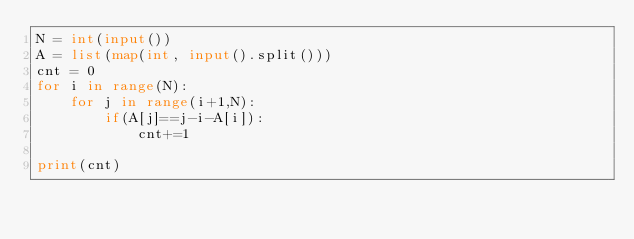<code> <loc_0><loc_0><loc_500><loc_500><_Python_>N = int(input())
A = list(map(int, input().split()))
cnt = 0 
for i in range(N):
    for j in range(i+1,N):
        if(A[j]==j-i-A[i]):
            cnt+=1

print(cnt)</code> 